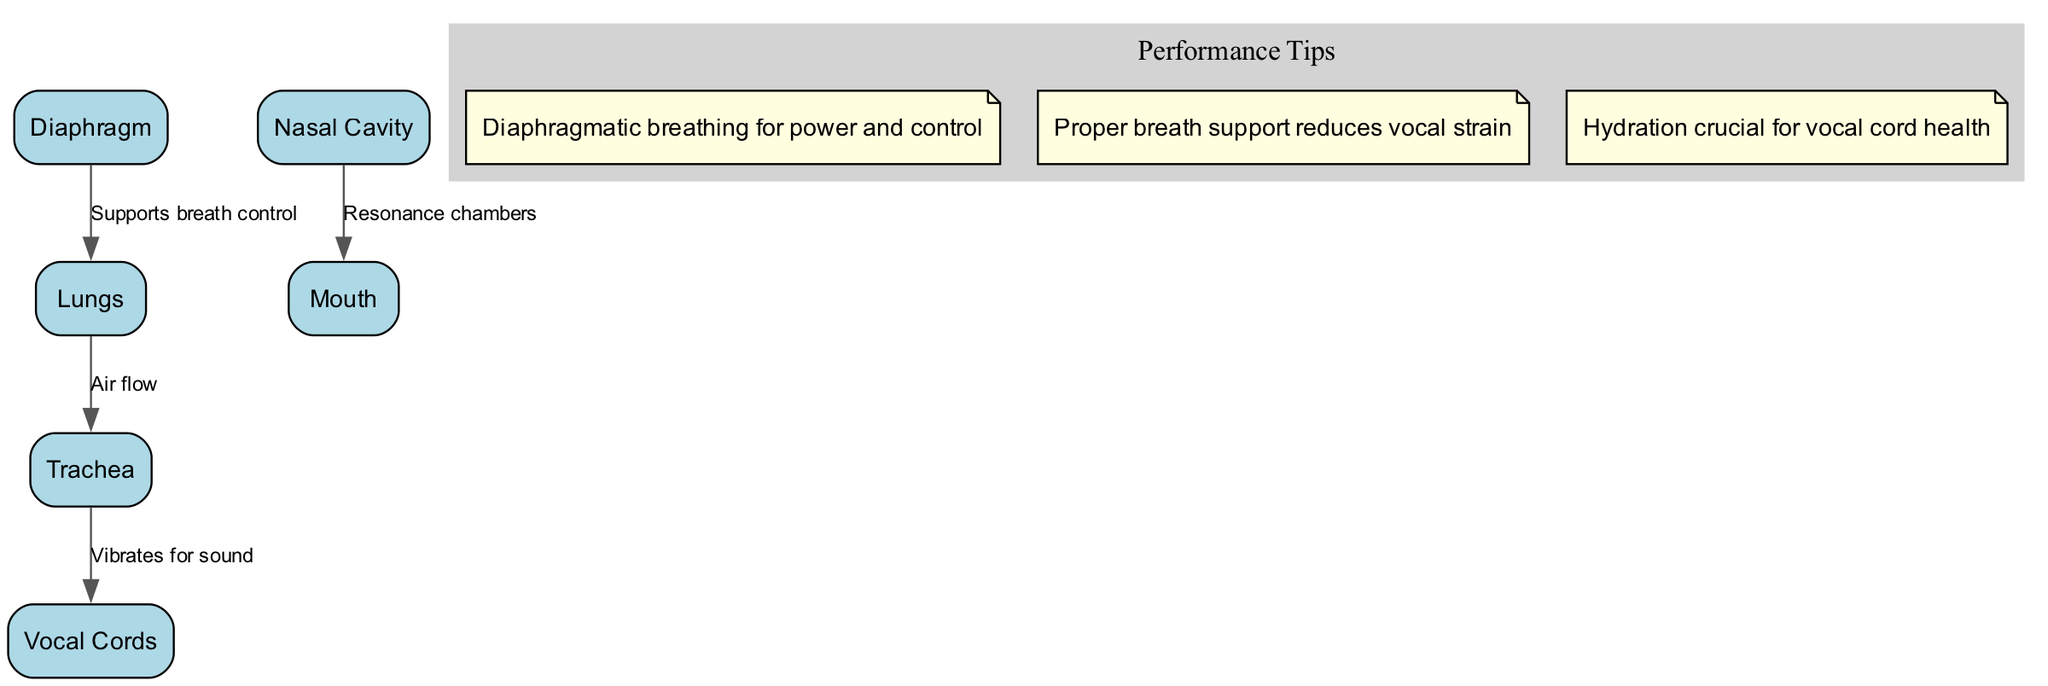What are the nodes in the diagram? The diagram includes several nodes, specifically: Lungs, Diaphragm, Vocal Cords, Trachea, Nasal Cavity, and Mouth. As we look at the nodes listed in the diagram, we can identify these six components related to the respiratory system.
Answer: Lungs, Diaphragm, Vocal Cords, Trachea, Nasal Cavity, Mouth How many edges are in the diagram? By counting the connections (or edges) between the nodes as indicated in the diagram, we find there are four edges: Diaphragm to Lungs, Lungs to Trachea, Trachea to Vocal Cords, and Nasal Cavity to Mouth. Therefore, the total count of edges is four.
Answer: 4 What does the edge from the diaphragm to the lungs indicate? The edge from the diaphragm to the lungs describes a relationship where the diaphragm supports breath control. This means that the diaphragm plays a crucial role in managing how air flows into the lungs for optimal vocal performance.
Answer: Supports breath control Which part of the respiratory system vibrates to produce sound? The part of the respiratory system that vibrates to produce sound is the Vocal Cords. By examining the diagram, it is clear from the connection flowing from the trachea to the vocal cords that they are responsible for sound production through vibration.
Answer: Vocal Cords What is the significance of the nasal cavity to the mouth? The significance of the nasal cavity to the mouth, as described by the edge connecting them in the diagram, is that they serve as resonance chambers. This means they help to amplify and enrich the sound produced by the vocal cords during singing.
Answer: Resonance chambers Which breathing technique is suggested for vocal power and control? The diagram notes that diaphragmatic breathing is the recommended technique for achieving power and control in vocal performance. By focusing on breathing using the diaphragm, one can support stronger vocalization.
Answer: Diaphragmatic breathing How does proper breath support affect vocal strain? Proper breath support, as indicated in the diagram's annotations, reduces vocal strain. This means that when a singer uses the proper techniques for breathing, it helps to lessen the stress placed on the vocal cords, leading to healthier singing.
Answer: Reduces vocal strain What health aspect is crucial for the vocal cords according to the diagram? The diagram emphasizes that hydration is crucial for vocal cord health. This points to the importance of staying hydrated to ensure optimal function and maintenance of the vocal cords during performances.
Answer: Hydration 